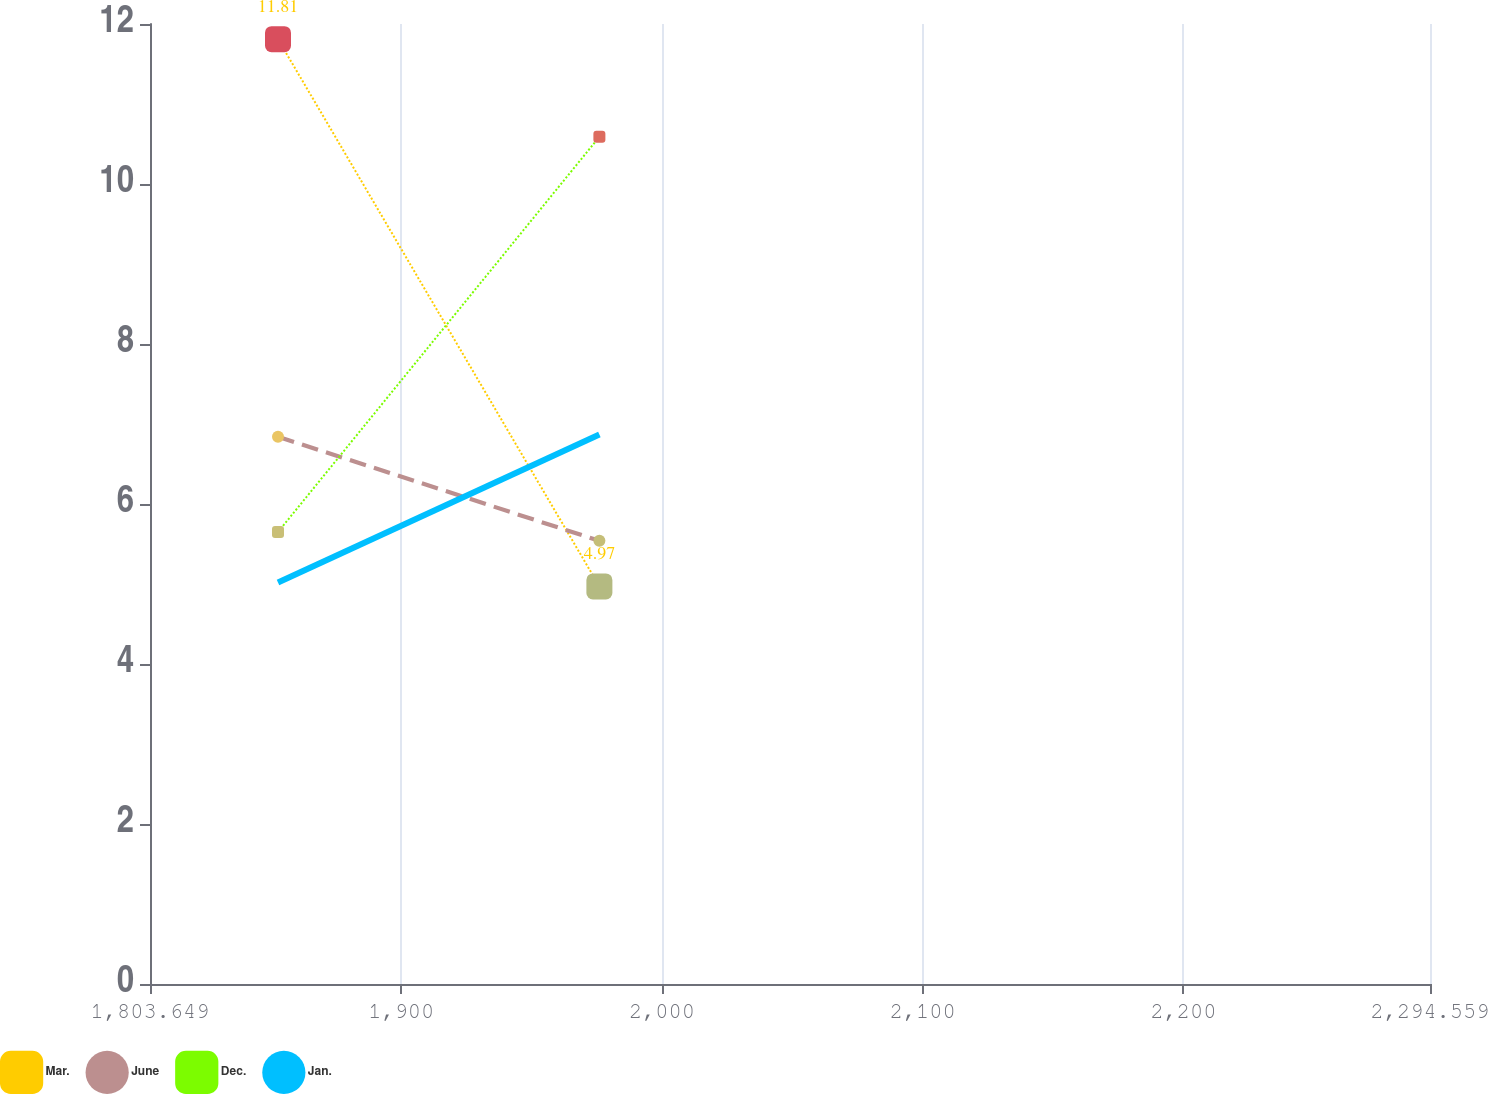<chart> <loc_0><loc_0><loc_500><loc_500><line_chart><ecel><fcel>Mar.<fcel>June<fcel>Dec.<fcel>Jan.<nl><fcel>1852.74<fcel>11.81<fcel>6.84<fcel>5.65<fcel>5.02<nl><fcel>1976<fcel>4.97<fcel>5.54<fcel>10.59<fcel>6.87<nl><fcel>2343.65<fcel>2.86<fcel>6.72<fcel>2.51<fcel>1.68<nl></chart> 